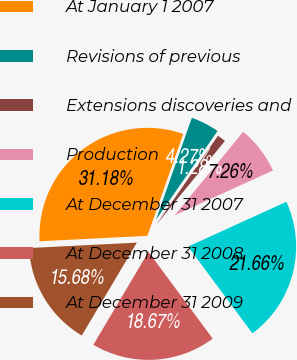Convert chart. <chart><loc_0><loc_0><loc_500><loc_500><pie_chart><fcel>At January 1 2007<fcel>Revisions of previous<fcel>Extensions discoveries and<fcel>Production<fcel>At December 31 2007<fcel>At December 31 2008<fcel>At December 31 2009<nl><fcel>31.18%<fcel>4.27%<fcel>1.28%<fcel>7.26%<fcel>21.66%<fcel>18.67%<fcel>15.68%<nl></chart> 